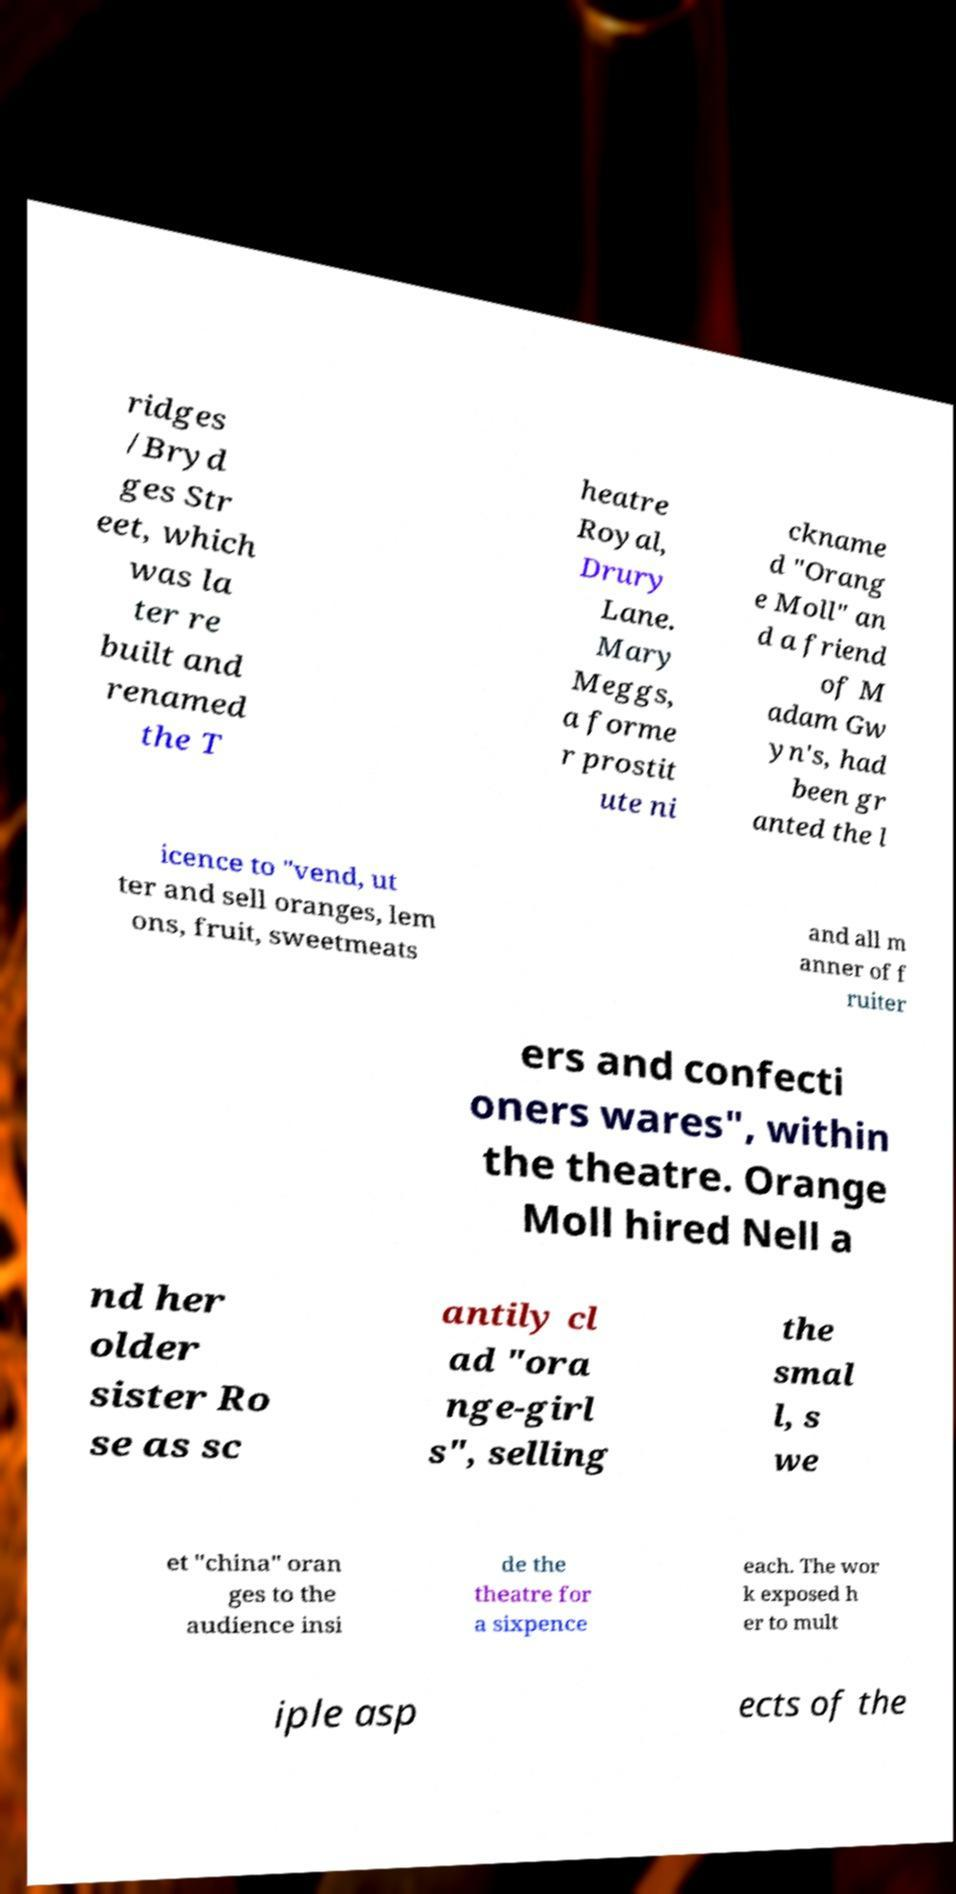Can you accurately transcribe the text from the provided image for me? ridges /Bryd ges Str eet, which was la ter re built and renamed the T heatre Royal, Drury Lane. Mary Meggs, a forme r prostit ute ni ckname d "Orang e Moll" an d a friend of M adam Gw yn's, had been gr anted the l icence to "vend, ut ter and sell oranges, lem ons, fruit, sweetmeats and all m anner of f ruiter ers and confecti oners wares", within the theatre. Orange Moll hired Nell a nd her older sister Ro se as sc antily cl ad "ora nge-girl s", selling the smal l, s we et "china" oran ges to the audience insi de the theatre for a sixpence each. The wor k exposed h er to mult iple asp ects of the 